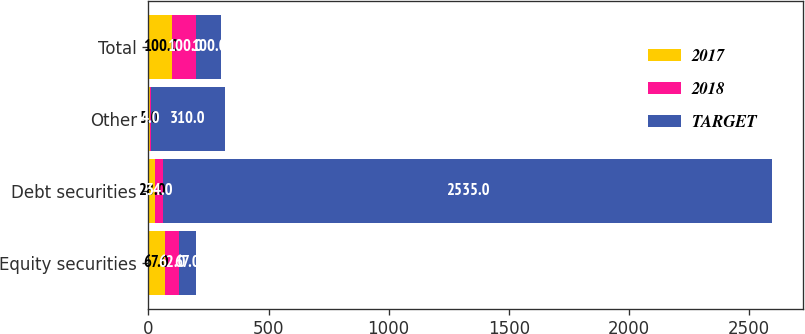Convert chart. <chart><loc_0><loc_0><loc_500><loc_500><stacked_bar_chart><ecel><fcel>Equity securities<fcel>Debt securities<fcel>Other<fcel>Total<nl><fcel>2017<fcel>67<fcel>28<fcel>5<fcel>100<nl><fcel>2018<fcel>62<fcel>34<fcel>4<fcel>100<nl><fcel>TARGET<fcel>67<fcel>2535<fcel>310<fcel>100<nl></chart> 